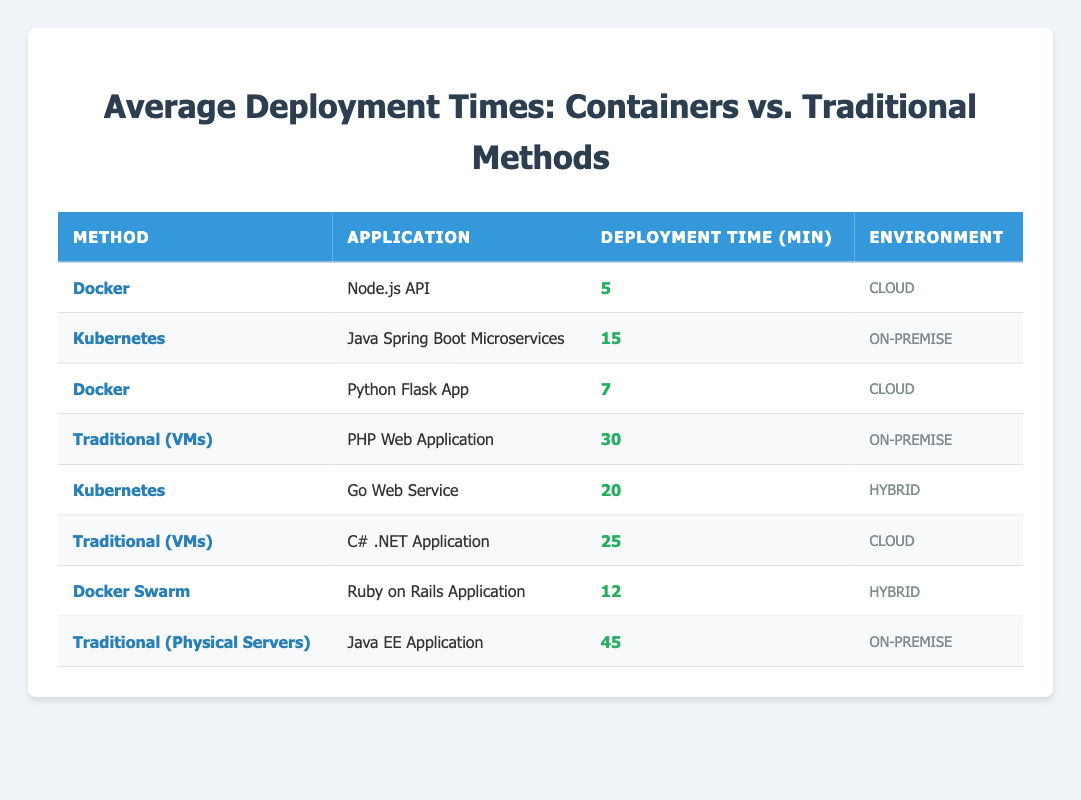What is the average deployment time for applications using Docker? The deployment times for applications using Docker are 5 minutes for the Node.js API and 7 minutes for the Python Flask App. To find the average, I sum these times: 5 + 7 = 12. Then I divide by the number of applications: 12 / 2 = 6.
Answer: 6 minutes Which method has the longest average deployment time? The table indicates that the "Traditional (Physical Servers)" method has an average deployment time of 45 minutes, which is longer than any of the other methods.
Answer: Traditional (Physical Servers) Is the average deployment time for Kubernetes applications shorter than that for Traditional (VMs) applications? The average deployment time for Kubernetes applications is 15 minutes for the Java Spring Boot Microservices and 20 minutes for the Go Web Service, totaling 35 minutes. This gives an average of 35 / 2 = 17.5 minutes. For Traditional (VMs), the times are 30 minutes (PHP Web Application) and 25 minutes (C# .NET Application), totaling 55 minutes, leading to an average of 55 / 2 = 27.5 minutes. Since 17.5 is less than 27.5, Kubernetes applications indeed have a shorter average deployment time.
Answer: Yes What is the difference in average deployment time between Docker and Traditional (VMs)? The average deployment time for Docker applications is (5 + 7) / 2 = 6 minutes, while the average for Traditional (VMs) applications is (30 + 25) / 2 = 27.5 minutes. To find the difference, I subtract the average Docker time from the average Traditional (VMs) time: 27.5 - 6 = 21.5 minutes.
Answer: 21.5 minutes How many applications have deployment times greater than 15 minutes? The applications with deployment times greater than 15 minutes are the PHP Web Application (30 min), C# .NET Application (25 min), Go Web Service (20 min), and Java EE Application (45 min). This gives us a total of four applications.
Answer: 4 applications Is it true that the Docker method has the fastest deployment time? The table shows that the fastest deployment times are 5 minutes for the Node.js API and 7 minutes for the Python Flask App under the Docker method, while the next fastest method, Docker Swarm, has an average time of 12 minutes. Since both times under Docker are faster than any other listed method, the statement is true.
Answer: Yes What is the total average deployment time across all application methods? To calculate the total average, I first sum all deployment times: 5 (Docker) + 15 (Kubernetes) + 7 (Docker) + 30 (Traditional VMs) + 20 (Kubernetes) + 25 (Traditional VMs) + 12 (Docker Swarm) + 45 (Traditional Physical Servers) = 159 minutes. Then I divide by the total number of applications (8): 159 / 8 = 19.875 minutes.
Answer: 19.875 minutes 